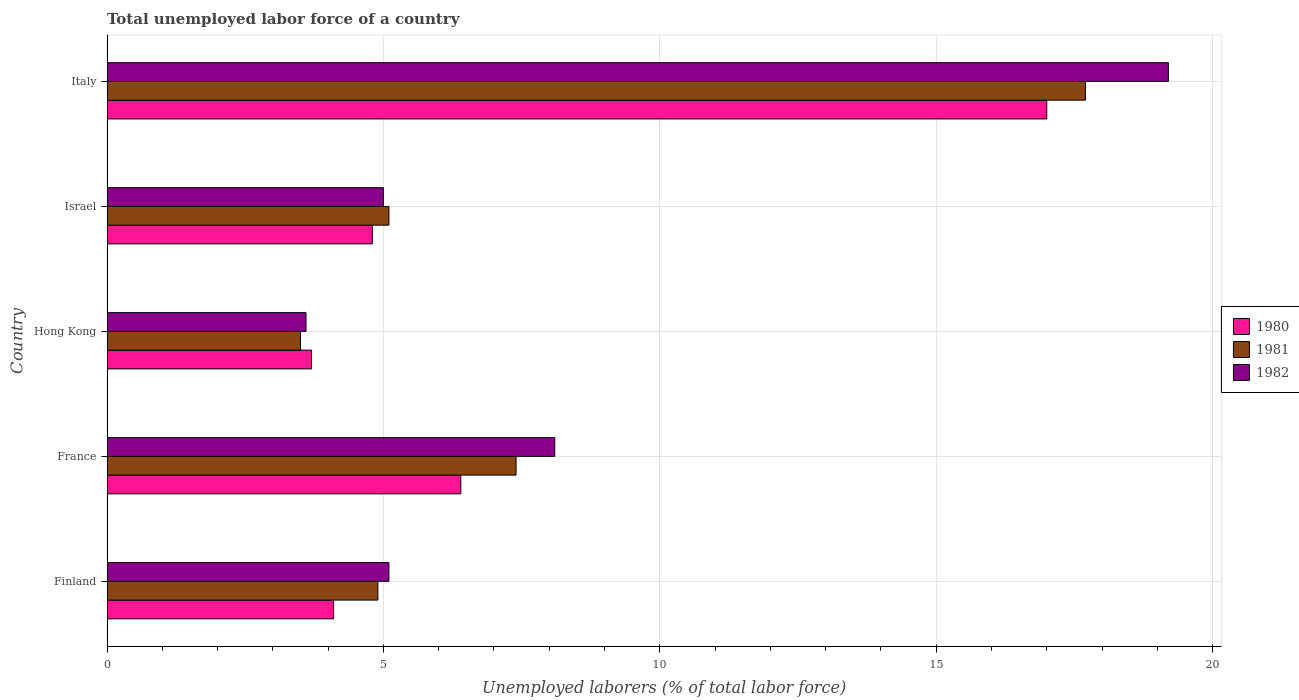Are the number of bars per tick equal to the number of legend labels?
Your answer should be compact. Yes. Are the number of bars on each tick of the Y-axis equal?
Your answer should be compact. Yes. How many bars are there on the 1st tick from the top?
Keep it short and to the point. 3. What is the label of the 2nd group of bars from the top?
Offer a terse response. Israel. What is the total unemployed labor force in 1982 in Italy?
Give a very brief answer. 19.2. Across all countries, what is the maximum total unemployed labor force in 1980?
Provide a short and direct response. 17. Across all countries, what is the minimum total unemployed labor force in 1980?
Give a very brief answer. 3.7. In which country was the total unemployed labor force in 1982 maximum?
Your answer should be compact. Italy. In which country was the total unemployed labor force in 1980 minimum?
Provide a succinct answer. Hong Kong. What is the total total unemployed labor force in 1980 in the graph?
Your response must be concise. 36. What is the difference between the total unemployed labor force in 1982 in France and that in Italy?
Ensure brevity in your answer.  -11.1. What is the difference between the total unemployed labor force in 1980 in Italy and the total unemployed labor force in 1982 in France?
Ensure brevity in your answer.  8.9. What is the average total unemployed labor force in 1980 per country?
Keep it short and to the point. 7.2. What is the difference between the total unemployed labor force in 1980 and total unemployed labor force in 1981 in Finland?
Your answer should be compact. -0.8. What is the ratio of the total unemployed labor force in 1982 in Finland to that in Hong Kong?
Your response must be concise. 1.42. Is the total unemployed labor force in 1980 in Hong Kong less than that in Italy?
Your answer should be very brief. Yes. What is the difference between the highest and the second highest total unemployed labor force in 1982?
Give a very brief answer. 11.1. What is the difference between the highest and the lowest total unemployed labor force in 1981?
Make the answer very short. 14.2. Is the sum of the total unemployed labor force in 1982 in Finland and Italy greater than the maximum total unemployed labor force in 1981 across all countries?
Your answer should be very brief. Yes. What does the 3rd bar from the top in Italy represents?
Your response must be concise. 1980. What does the 3rd bar from the bottom in France represents?
Give a very brief answer. 1982. Is it the case that in every country, the sum of the total unemployed labor force in 1980 and total unemployed labor force in 1982 is greater than the total unemployed labor force in 1981?
Provide a succinct answer. Yes. Does the graph contain any zero values?
Offer a terse response. No. Does the graph contain grids?
Keep it short and to the point. Yes. How many legend labels are there?
Provide a succinct answer. 3. What is the title of the graph?
Offer a very short reply. Total unemployed labor force of a country. What is the label or title of the X-axis?
Offer a very short reply. Unemployed laborers (% of total labor force). What is the label or title of the Y-axis?
Keep it short and to the point. Country. What is the Unemployed laborers (% of total labor force) of 1980 in Finland?
Offer a terse response. 4.1. What is the Unemployed laborers (% of total labor force) of 1981 in Finland?
Your answer should be compact. 4.9. What is the Unemployed laborers (% of total labor force) of 1982 in Finland?
Make the answer very short. 5.1. What is the Unemployed laborers (% of total labor force) of 1980 in France?
Make the answer very short. 6.4. What is the Unemployed laborers (% of total labor force) of 1981 in France?
Offer a terse response. 7.4. What is the Unemployed laborers (% of total labor force) in 1982 in France?
Give a very brief answer. 8.1. What is the Unemployed laborers (% of total labor force) in 1980 in Hong Kong?
Offer a terse response. 3.7. What is the Unemployed laborers (% of total labor force) of 1982 in Hong Kong?
Your answer should be very brief. 3.6. What is the Unemployed laborers (% of total labor force) in 1980 in Israel?
Offer a very short reply. 4.8. What is the Unemployed laborers (% of total labor force) in 1981 in Israel?
Your answer should be compact. 5.1. What is the Unemployed laborers (% of total labor force) of 1980 in Italy?
Your answer should be compact. 17. What is the Unemployed laborers (% of total labor force) of 1981 in Italy?
Offer a terse response. 17.7. What is the Unemployed laborers (% of total labor force) in 1982 in Italy?
Give a very brief answer. 19.2. Across all countries, what is the maximum Unemployed laborers (% of total labor force) in 1981?
Offer a very short reply. 17.7. Across all countries, what is the maximum Unemployed laborers (% of total labor force) of 1982?
Make the answer very short. 19.2. Across all countries, what is the minimum Unemployed laborers (% of total labor force) of 1980?
Provide a short and direct response. 3.7. Across all countries, what is the minimum Unemployed laborers (% of total labor force) of 1981?
Give a very brief answer. 3.5. Across all countries, what is the minimum Unemployed laborers (% of total labor force) in 1982?
Offer a very short reply. 3.6. What is the total Unemployed laborers (% of total labor force) in 1981 in the graph?
Your answer should be very brief. 38.6. What is the difference between the Unemployed laborers (% of total labor force) of 1980 in Finland and that in France?
Provide a succinct answer. -2.3. What is the difference between the Unemployed laborers (% of total labor force) in 1981 in Finland and that in Hong Kong?
Provide a short and direct response. 1.4. What is the difference between the Unemployed laborers (% of total labor force) of 1982 in Finland and that in Hong Kong?
Your answer should be compact. 1.5. What is the difference between the Unemployed laborers (% of total labor force) of 1980 in Finland and that in Israel?
Your answer should be very brief. -0.7. What is the difference between the Unemployed laborers (% of total labor force) of 1980 in Finland and that in Italy?
Offer a very short reply. -12.9. What is the difference between the Unemployed laborers (% of total labor force) in 1981 in Finland and that in Italy?
Offer a very short reply. -12.8. What is the difference between the Unemployed laborers (% of total labor force) in 1982 in Finland and that in Italy?
Your answer should be very brief. -14.1. What is the difference between the Unemployed laborers (% of total labor force) in 1982 in France and that in Hong Kong?
Your answer should be very brief. 4.5. What is the difference between the Unemployed laborers (% of total labor force) of 1980 in France and that in Israel?
Your answer should be very brief. 1.6. What is the difference between the Unemployed laborers (% of total labor force) in 1981 in Hong Kong and that in Italy?
Offer a terse response. -14.2. What is the difference between the Unemployed laborers (% of total labor force) in 1982 in Hong Kong and that in Italy?
Give a very brief answer. -15.6. What is the difference between the Unemployed laborers (% of total labor force) in 1982 in Israel and that in Italy?
Your answer should be compact. -14.2. What is the difference between the Unemployed laborers (% of total labor force) of 1981 in Finland and the Unemployed laborers (% of total labor force) of 1982 in France?
Offer a very short reply. -3.2. What is the difference between the Unemployed laborers (% of total labor force) in 1980 in Finland and the Unemployed laborers (% of total labor force) in 1981 in Israel?
Your response must be concise. -1. What is the difference between the Unemployed laborers (% of total labor force) of 1980 in Finland and the Unemployed laborers (% of total labor force) of 1982 in Israel?
Make the answer very short. -0.9. What is the difference between the Unemployed laborers (% of total labor force) of 1980 in Finland and the Unemployed laborers (% of total labor force) of 1982 in Italy?
Provide a succinct answer. -15.1. What is the difference between the Unemployed laborers (% of total labor force) of 1981 in Finland and the Unemployed laborers (% of total labor force) of 1982 in Italy?
Keep it short and to the point. -14.3. What is the difference between the Unemployed laborers (% of total labor force) of 1980 in France and the Unemployed laborers (% of total labor force) of 1981 in Hong Kong?
Ensure brevity in your answer.  2.9. What is the difference between the Unemployed laborers (% of total labor force) of 1980 in France and the Unemployed laborers (% of total labor force) of 1982 in Hong Kong?
Offer a very short reply. 2.8. What is the difference between the Unemployed laborers (% of total labor force) of 1980 in France and the Unemployed laborers (% of total labor force) of 1981 in Israel?
Your answer should be compact. 1.3. What is the difference between the Unemployed laborers (% of total labor force) in 1980 in France and the Unemployed laborers (% of total labor force) in 1982 in Israel?
Give a very brief answer. 1.4. What is the difference between the Unemployed laborers (% of total labor force) of 1981 in France and the Unemployed laborers (% of total labor force) of 1982 in Israel?
Your answer should be very brief. 2.4. What is the difference between the Unemployed laborers (% of total labor force) in 1980 in France and the Unemployed laborers (% of total labor force) in 1982 in Italy?
Your answer should be very brief. -12.8. What is the difference between the Unemployed laborers (% of total labor force) of 1980 in Hong Kong and the Unemployed laborers (% of total labor force) of 1981 in Israel?
Give a very brief answer. -1.4. What is the difference between the Unemployed laborers (% of total labor force) of 1980 in Hong Kong and the Unemployed laborers (% of total labor force) of 1982 in Israel?
Your answer should be very brief. -1.3. What is the difference between the Unemployed laborers (% of total labor force) of 1981 in Hong Kong and the Unemployed laborers (% of total labor force) of 1982 in Israel?
Offer a very short reply. -1.5. What is the difference between the Unemployed laborers (% of total labor force) in 1980 in Hong Kong and the Unemployed laborers (% of total labor force) in 1981 in Italy?
Offer a terse response. -14. What is the difference between the Unemployed laborers (% of total labor force) of 1980 in Hong Kong and the Unemployed laborers (% of total labor force) of 1982 in Italy?
Provide a succinct answer. -15.5. What is the difference between the Unemployed laborers (% of total labor force) in 1981 in Hong Kong and the Unemployed laborers (% of total labor force) in 1982 in Italy?
Give a very brief answer. -15.7. What is the difference between the Unemployed laborers (% of total labor force) of 1980 in Israel and the Unemployed laborers (% of total labor force) of 1982 in Italy?
Ensure brevity in your answer.  -14.4. What is the difference between the Unemployed laborers (% of total labor force) in 1981 in Israel and the Unemployed laborers (% of total labor force) in 1982 in Italy?
Offer a very short reply. -14.1. What is the average Unemployed laborers (% of total labor force) in 1980 per country?
Provide a short and direct response. 7.2. What is the average Unemployed laborers (% of total labor force) of 1981 per country?
Ensure brevity in your answer.  7.72. What is the difference between the Unemployed laborers (% of total labor force) of 1980 and Unemployed laborers (% of total labor force) of 1982 in Finland?
Your answer should be compact. -1. What is the difference between the Unemployed laborers (% of total labor force) of 1980 and Unemployed laborers (% of total labor force) of 1981 in France?
Your answer should be compact. -1. What is the difference between the Unemployed laborers (% of total labor force) in 1980 and Unemployed laborers (% of total labor force) in 1982 in France?
Your response must be concise. -1.7. What is the difference between the Unemployed laborers (% of total labor force) of 1980 and Unemployed laborers (% of total labor force) of 1981 in Hong Kong?
Provide a succinct answer. 0.2. What is the difference between the Unemployed laborers (% of total labor force) of 1980 and Unemployed laborers (% of total labor force) of 1982 in Hong Kong?
Your response must be concise. 0.1. What is the difference between the Unemployed laborers (% of total labor force) in 1980 and Unemployed laborers (% of total labor force) in 1981 in Israel?
Ensure brevity in your answer.  -0.3. What is the difference between the Unemployed laborers (% of total labor force) in 1980 and Unemployed laborers (% of total labor force) in 1981 in Italy?
Your answer should be very brief. -0.7. What is the ratio of the Unemployed laborers (% of total labor force) of 1980 in Finland to that in France?
Keep it short and to the point. 0.64. What is the ratio of the Unemployed laborers (% of total labor force) in 1981 in Finland to that in France?
Keep it short and to the point. 0.66. What is the ratio of the Unemployed laborers (% of total labor force) in 1982 in Finland to that in France?
Offer a terse response. 0.63. What is the ratio of the Unemployed laborers (% of total labor force) of 1980 in Finland to that in Hong Kong?
Offer a terse response. 1.11. What is the ratio of the Unemployed laborers (% of total labor force) in 1981 in Finland to that in Hong Kong?
Keep it short and to the point. 1.4. What is the ratio of the Unemployed laborers (% of total labor force) of 1982 in Finland to that in Hong Kong?
Keep it short and to the point. 1.42. What is the ratio of the Unemployed laborers (% of total labor force) in 1980 in Finland to that in Israel?
Your answer should be compact. 0.85. What is the ratio of the Unemployed laborers (% of total labor force) in 1981 in Finland to that in Israel?
Ensure brevity in your answer.  0.96. What is the ratio of the Unemployed laborers (% of total labor force) in 1982 in Finland to that in Israel?
Your answer should be very brief. 1.02. What is the ratio of the Unemployed laborers (% of total labor force) in 1980 in Finland to that in Italy?
Ensure brevity in your answer.  0.24. What is the ratio of the Unemployed laborers (% of total labor force) in 1981 in Finland to that in Italy?
Offer a terse response. 0.28. What is the ratio of the Unemployed laborers (% of total labor force) of 1982 in Finland to that in Italy?
Offer a terse response. 0.27. What is the ratio of the Unemployed laborers (% of total labor force) of 1980 in France to that in Hong Kong?
Give a very brief answer. 1.73. What is the ratio of the Unemployed laborers (% of total labor force) in 1981 in France to that in Hong Kong?
Make the answer very short. 2.11. What is the ratio of the Unemployed laborers (% of total labor force) of 1982 in France to that in Hong Kong?
Offer a very short reply. 2.25. What is the ratio of the Unemployed laborers (% of total labor force) of 1980 in France to that in Israel?
Give a very brief answer. 1.33. What is the ratio of the Unemployed laborers (% of total labor force) of 1981 in France to that in Israel?
Your response must be concise. 1.45. What is the ratio of the Unemployed laborers (% of total labor force) of 1982 in France to that in Israel?
Keep it short and to the point. 1.62. What is the ratio of the Unemployed laborers (% of total labor force) in 1980 in France to that in Italy?
Ensure brevity in your answer.  0.38. What is the ratio of the Unemployed laborers (% of total labor force) of 1981 in France to that in Italy?
Keep it short and to the point. 0.42. What is the ratio of the Unemployed laborers (% of total labor force) of 1982 in France to that in Italy?
Make the answer very short. 0.42. What is the ratio of the Unemployed laborers (% of total labor force) in 1980 in Hong Kong to that in Israel?
Your answer should be very brief. 0.77. What is the ratio of the Unemployed laborers (% of total labor force) of 1981 in Hong Kong to that in Israel?
Your response must be concise. 0.69. What is the ratio of the Unemployed laborers (% of total labor force) of 1982 in Hong Kong to that in Israel?
Your answer should be very brief. 0.72. What is the ratio of the Unemployed laborers (% of total labor force) in 1980 in Hong Kong to that in Italy?
Offer a very short reply. 0.22. What is the ratio of the Unemployed laborers (% of total labor force) in 1981 in Hong Kong to that in Italy?
Make the answer very short. 0.2. What is the ratio of the Unemployed laborers (% of total labor force) of 1982 in Hong Kong to that in Italy?
Make the answer very short. 0.19. What is the ratio of the Unemployed laborers (% of total labor force) of 1980 in Israel to that in Italy?
Make the answer very short. 0.28. What is the ratio of the Unemployed laborers (% of total labor force) of 1981 in Israel to that in Italy?
Provide a short and direct response. 0.29. What is the ratio of the Unemployed laborers (% of total labor force) of 1982 in Israel to that in Italy?
Provide a short and direct response. 0.26. What is the difference between the highest and the second highest Unemployed laborers (% of total labor force) of 1980?
Provide a short and direct response. 10.6. What is the difference between the highest and the second highest Unemployed laborers (% of total labor force) in 1982?
Your answer should be compact. 11.1. 